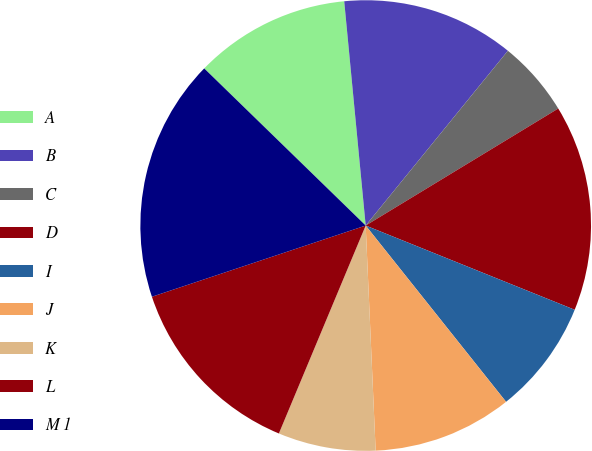Convert chart. <chart><loc_0><loc_0><loc_500><loc_500><pie_chart><fcel>A<fcel>B<fcel>C<fcel>D<fcel>I<fcel>J<fcel>K<fcel>L<fcel>M 1<nl><fcel>11.2%<fcel>12.39%<fcel>5.44%<fcel>14.79%<fcel>8.2%<fcel>10.0%<fcel>7.0%<fcel>13.59%<fcel>17.4%<nl></chart> 